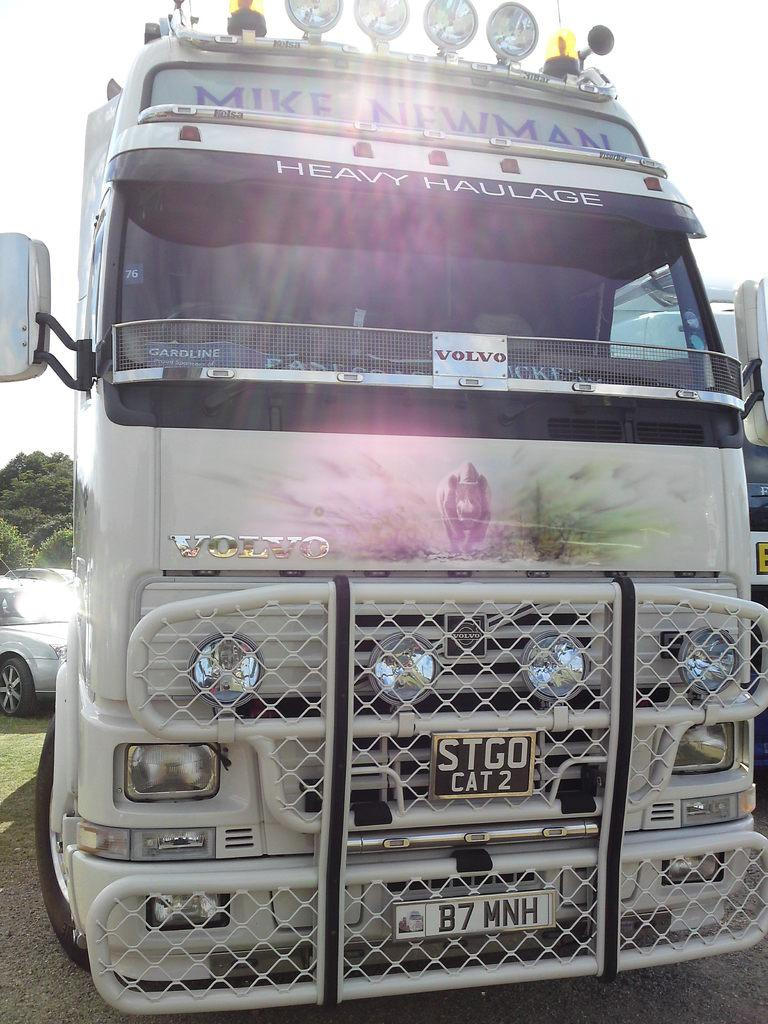Provide a one-sentence caption for the provided image. A semi truck with a large front grille says Volvo. 